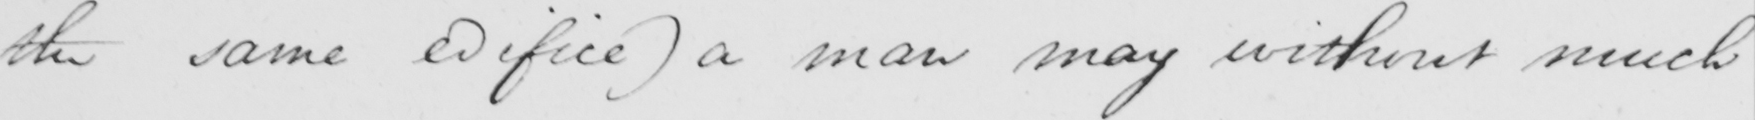Transcribe the text shown in this historical manuscript line. the same edifice )  a man may without much 